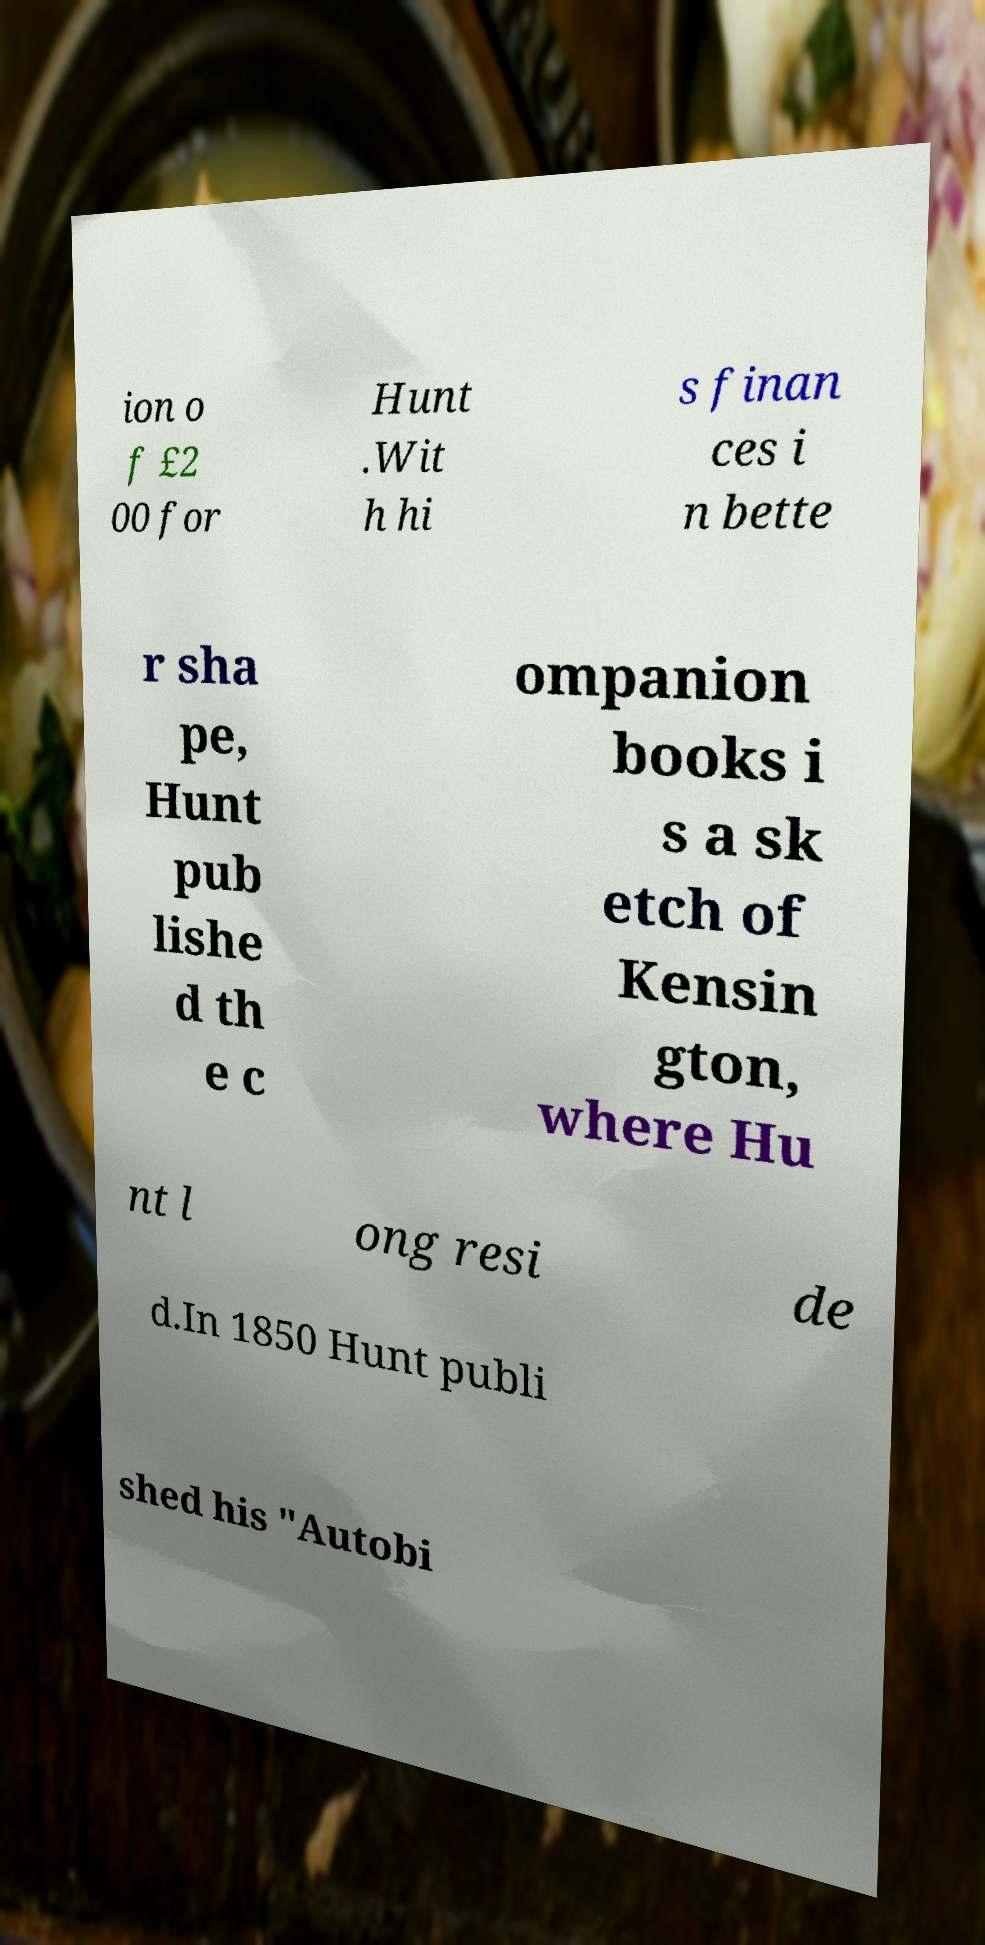Could you extract and type out the text from this image? ion o f £2 00 for Hunt .Wit h hi s finan ces i n bette r sha pe, Hunt pub lishe d th e c ompanion books i s a sk etch of Kensin gton, where Hu nt l ong resi de d.In 1850 Hunt publi shed his "Autobi 